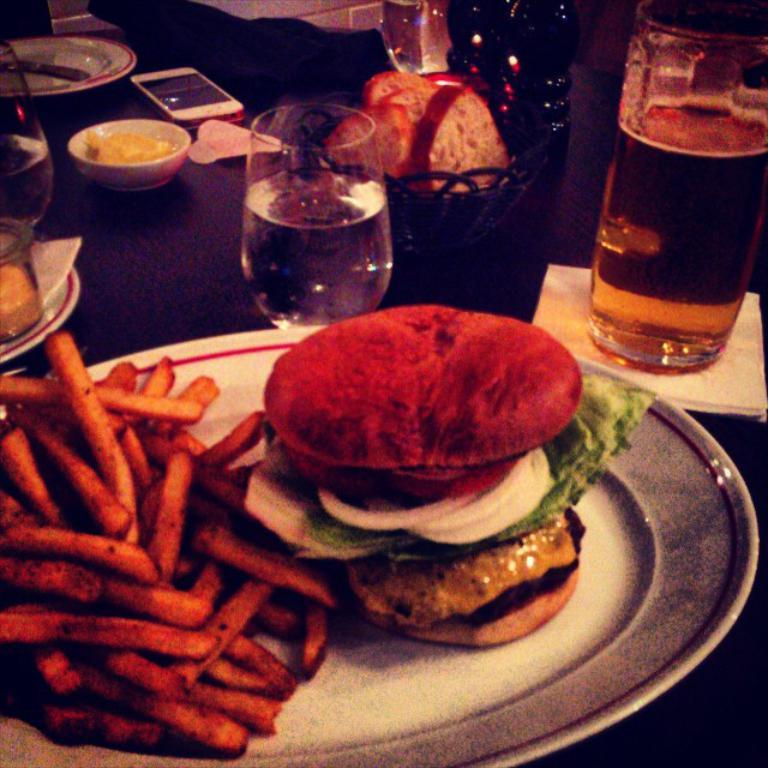What is on the table in the image? There is a plate on the table on the table. What is on the plate? There is a burger and french fries on the plate. What is beside the plate? There is a glass, a mobile, and a bowl with bread slices beside the plate. What type of cheese is on the lamp in the image? There is no lamp or cheese present in the image. How is the wrench being used in the image? There is no wrench present in the image. 